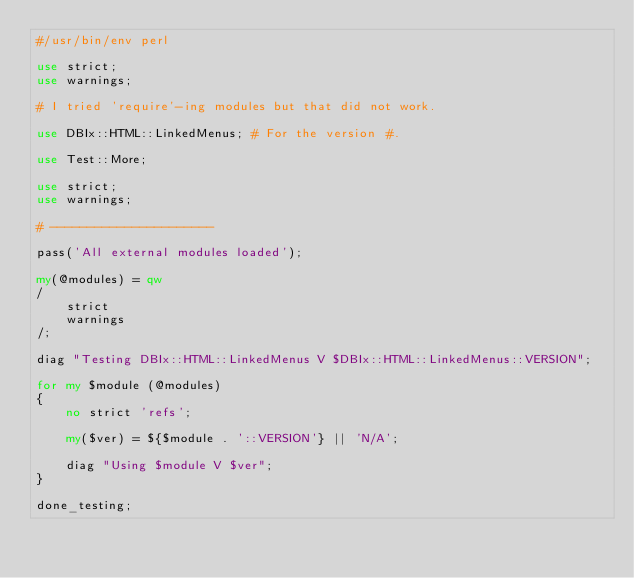Convert code to text. <code><loc_0><loc_0><loc_500><loc_500><_Perl_>#/usr/bin/env perl

use strict;
use warnings;

# I tried 'require'-ing modules but that did not work.

use DBIx::HTML::LinkedMenus; # For the version #.

use Test::More;

use strict;
use warnings;

# ----------------------

pass('All external modules loaded');

my(@modules) = qw
/
	strict
	warnings
/;

diag "Testing DBIx::HTML::LinkedMenus V $DBIx::HTML::LinkedMenus::VERSION";

for my $module (@modules)
{
	no strict 'refs';

	my($ver) = ${$module . '::VERSION'} || 'N/A';

	diag "Using $module V $ver";
}

done_testing;
</code> 